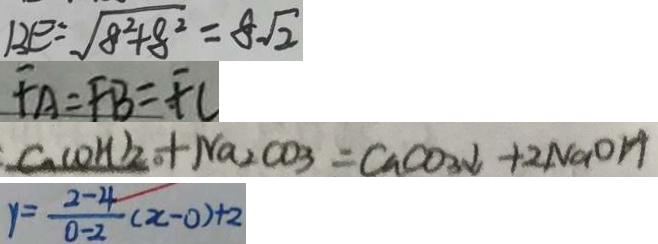<formula> <loc_0><loc_0><loc_500><loc_500>B E = \sqrt { 8 ^ { 2 } + 8 ^ { 2 } } = 8 \sqrt { 2 } 
 F A = F B = F C 
 C u ( O H ) _ { 2 } + N a _ { 2 } C O _ { 3 } = C a C O _ { 3 } \downarrow + 2 N a O H 
 y = \frac { 2 - 4 } { 0 - 2 } ( x - 0 ) + 2</formula> 